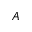Convert formula to latex. <formula><loc_0><loc_0><loc_500><loc_500>A</formula> 